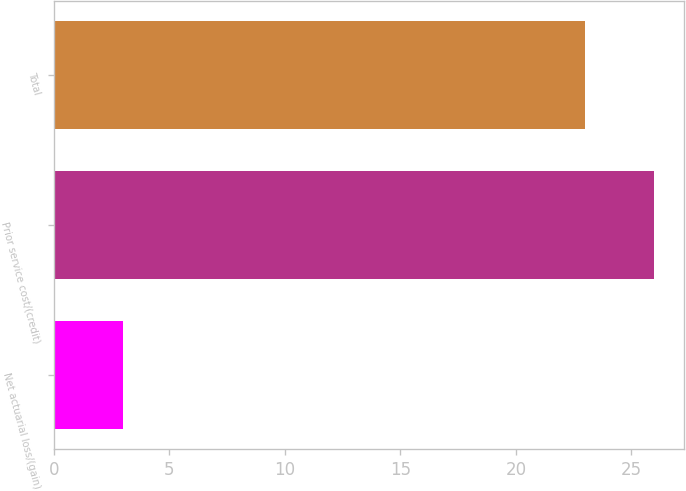Convert chart. <chart><loc_0><loc_0><loc_500><loc_500><bar_chart><fcel>Net actuarial loss/(gain)<fcel>Prior service cost/(credit)<fcel>Total<nl><fcel>3<fcel>26<fcel>23<nl></chart> 